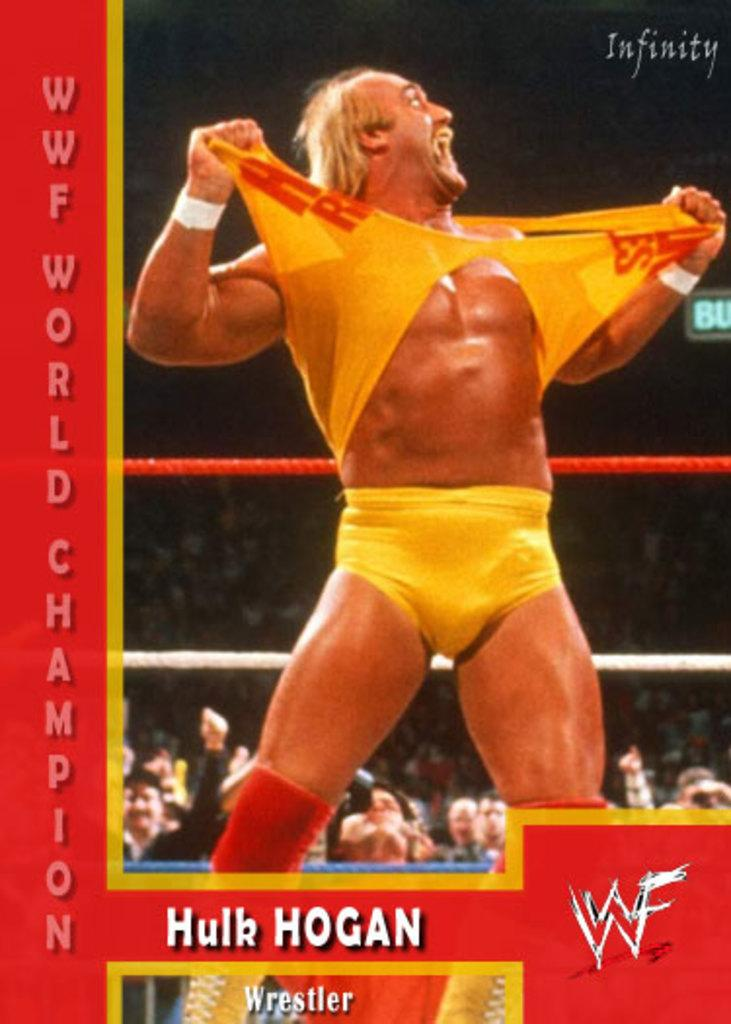<image>
Present a compact description of the photo's key features. The wrestler Hulk Hogan tears his top open during the WWF World Championships. 